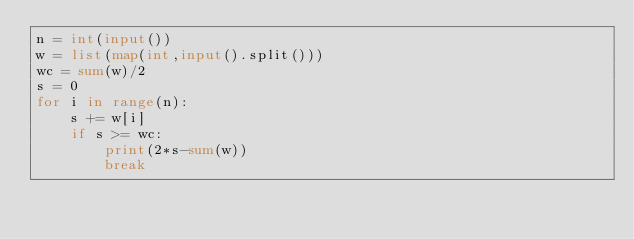Convert code to text. <code><loc_0><loc_0><loc_500><loc_500><_Python_>n = int(input())
w = list(map(int,input().split()))
wc = sum(w)/2
s = 0
for i in range(n):
    s += w[i]
    if s >= wc:
        print(2*s-sum(w))
        break</code> 